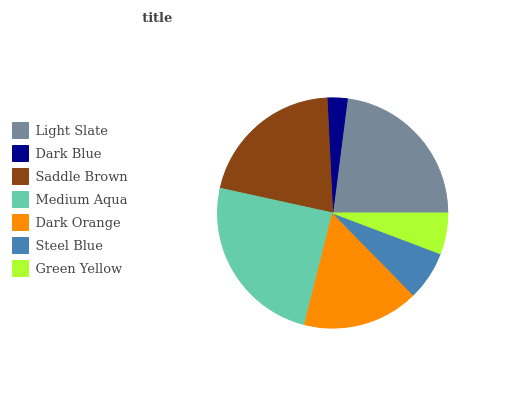Is Dark Blue the minimum?
Answer yes or no. Yes. Is Medium Aqua the maximum?
Answer yes or no. Yes. Is Saddle Brown the minimum?
Answer yes or no. No. Is Saddle Brown the maximum?
Answer yes or no. No. Is Saddle Brown greater than Dark Blue?
Answer yes or no. Yes. Is Dark Blue less than Saddle Brown?
Answer yes or no. Yes. Is Dark Blue greater than Saddle Brown?
Answer yes or no. No. Is Saddle Brown less than Dark Blue?
Answer yes or no. No. Is Dark Orange the high median?
Answer yes or no. Yes. Is Dark Orange the low median?
Answer yes or no. Yes. Is Steel Blue the high median?
Answer yes or no. No. Is Medium Aqua the low median?
Answer yes or no. No. 